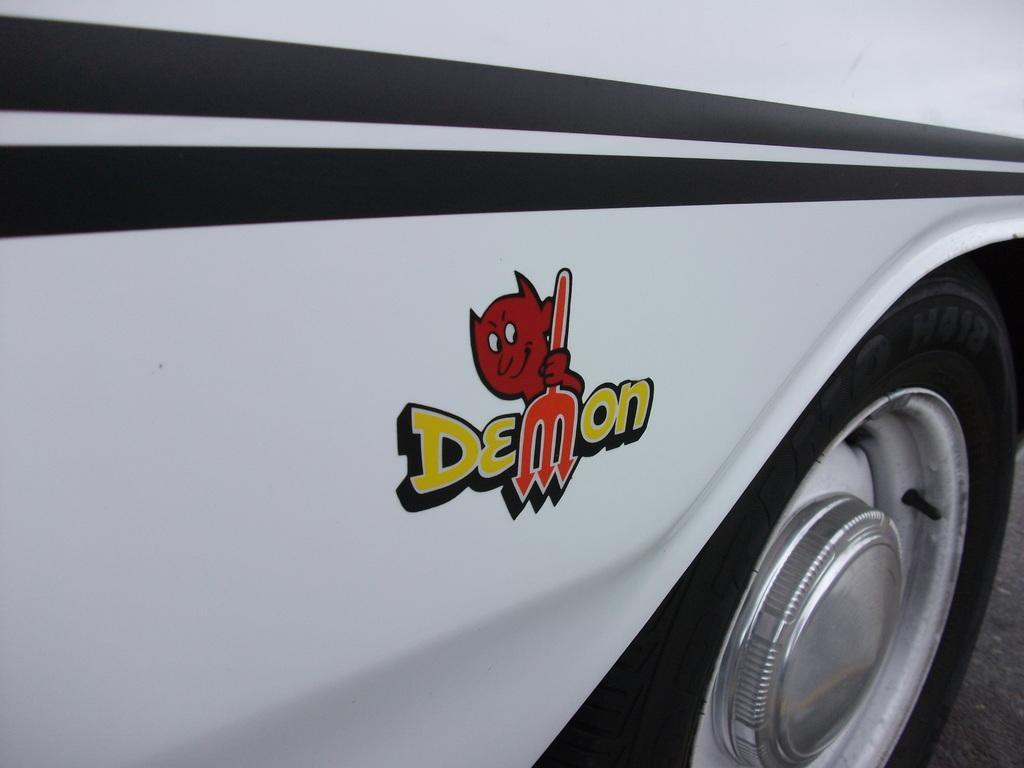Can you describe this image briefly? In this image I can see a vehicle which is white, black, red, orange and yellow in color is on the ground. 